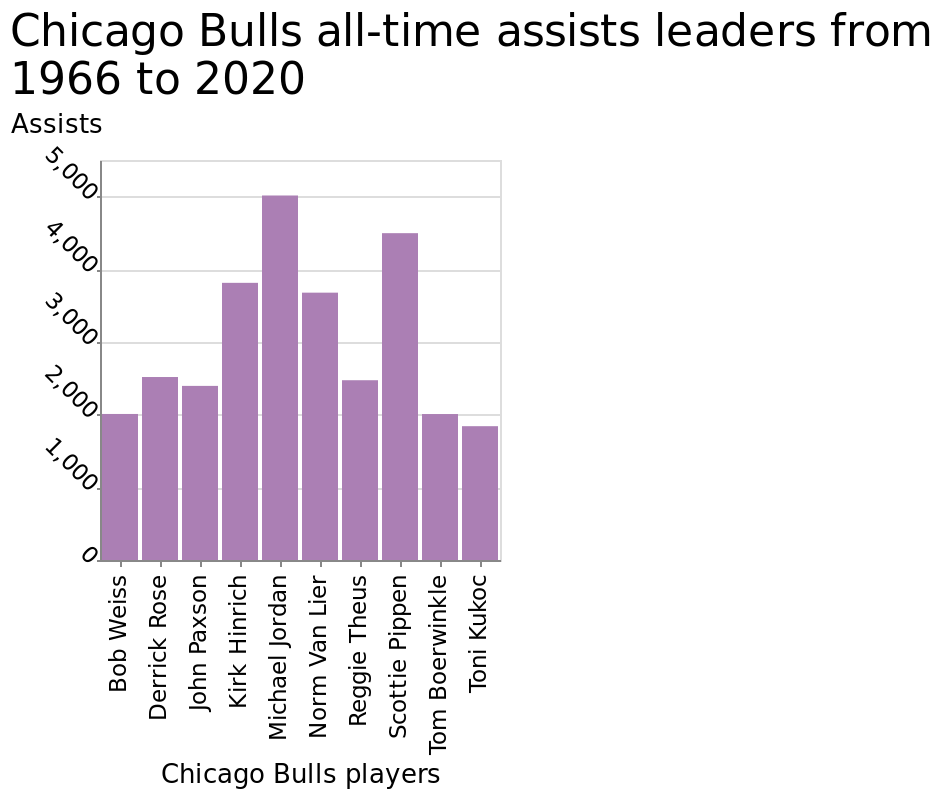<image>
What is represented on the y-axis of the bar chart? The y-axis of the bar chart represents the number of assists, ranging from 0 to 5,000. What is the time period covered by the bar chart? The bar chart covers the time period from 1966 to 2020. 